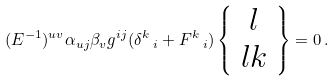<formula> <loc_0><loc_0><loc_500><loc_500>( E ^ { - 1 } ) ^ { u v } \alpha _ { u j } \beta _ { v } g ^ { i j } ( \delta ^ { k } \, _ { i } + F ^ { k } \, _ { i } ) \left \{ \begin{array} { c } { l } \\ { l k } \end{array} \right \} = 0 \, .</formula> 